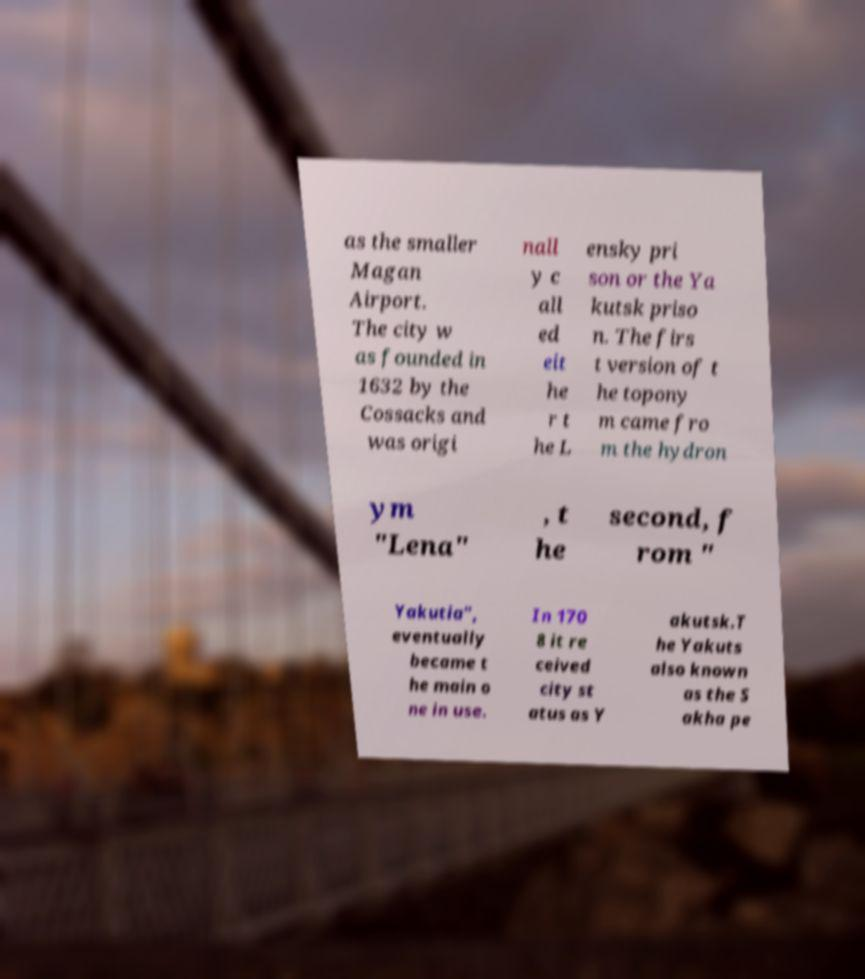Can you read and provide the text displayed in the image?This photo seems to have some interesting text. Can you extract and type it out for me? as the smaller Magan Airport. The city w as founded in 1632 by the Cossacks and was origi nall y c all ed eit he r t he L ensky pri son or the Ya kutsk priso n. The firs t version of t he topony m came fro m the hydron ym "Lena" , t he second, f rom " Yakutia", eventually became t he main o ne in use. In 170 8 it re ceived city st atus as Y akutsk.T he Yakuts also known as the S akha pe 